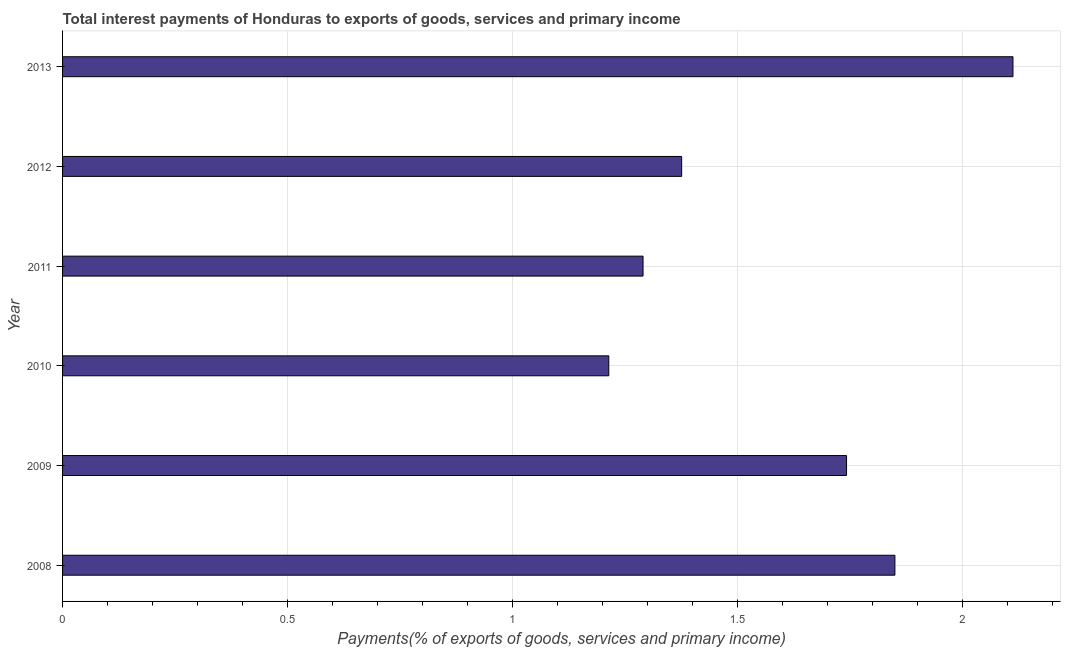Does the graph contain grids?
Provide a short and direct response. Yes. What is the title of the graph?
Your response must be concise. Total interest payments of Honduras to exports of goods, services and primary income. What is the label or title of the X-axis?
Provide a short and direct response. Payments(% of exports of goods, services and primary income). What is the total interest payments on external debt in 2008?
Offer a terse response. 1.85. Across all years, what is the maximum total interest payments on external debt?
Your response must be concise. 2.11. Across all years, what is the minimum total interest payments on external debt?
Provide a succinct answer. 1.21. In which year was the total interest payments on external debt maximum?
Provide a short and direct response. 2013. In which year was the total interest payments on external debt minimum?
Keep it short and to the point. 2010. What is the sum of the total interest payments on external debt?
Offer a terse response. 9.58. What is the difference between the total interest payments on external debt in 2010 and 2011?
Your answer should be compact. -0.08. What is the average total interest payments on external debt per year?
Provide a succinct answer. 1.6. What is the median total interest payments on external debt?
Give a very brief answer. 1.56. What is the ratio of the total interest payments on external debt in 2010 to that in 2012?
Ensure brevity in your answer.  0.88. Is the difference between the total interest payments on external debt in 2008 and 2009 greater than the difference between any two years?
Your answer should be very brief. No. What is the difference between the highest and the second highest total interest payments on external debt?
Ensure brevity in your answer.  0.26. What is the difference between the highest and the lowest total interest payments on external debt?
Provide a succinct answer. 0.9. In how many years, is the total interest payments on external debt greater than the average total interest payments on external debt taken over all years?
Keep it short and to the point. 3. Are all the bars in the graph horizontal?
Make the answer very short. Yes. What is the Payments(% of exports of goods, services and primary income) of 2008?
Offer a very short reply. 1.85. What is the Payments(% of exports of goods, services and primary income) of 2009?
Your response must be concise. 1.74. What is the Payments(% of exports of goods, services and primary income) in 2010?
Keep it short and to the point. 1.21. What is the Payments(% of exports of goods, services and primary income) in 2011?
Give a very brief answer. 1.29. What is the Payments(% of exports of goods, services and primary income) in 2012?
Provide a succinct answer. 1.38. What is the Payments(% of exports of goods, services and primary income) of 2013?
Provide a short and direct response. 2.11. What is the difference between the Payments(% of exports of goods, services and primary income) in 2008 and 2009?
Your answer should be compact. 0.11. What is the difference between the Payments(% of exports of goods, services and primary income) in 2008 and 2010?
Offer a very short reply. 0.64. What is the difference between the Payments(% of exports of goods, services and primary income) in 2008 and 2011?
Keep it short and to the point. 0.56. What is the difference between the Payments(% of exports of goods, services and primary income) in 2008 and 2012?
Offer a very short reply. 0.47. What is the difference between the Payments(% of exports of goods, services and primary income) in 2008 and 2013?
Your response must be concise. -0.26. What is the difference between the Payments(% of exports of goods, services and primary income) in 2009 and 2010?
Keep it short and to the point. 0.53. What is the difference between the Payments(% of exports of goods, services and primary income) in 2009 and 2011?
Offer a very short reply. 0.45. What is the difference between the Payments(% of exports of goods, services and primary income) in 2009 and 2012?
Offer a very short reply. 0.37. What is the difference between the Payments(% of exports of goods, services and primary income) in 2009 and 2013?
Provide a succinct answer. -0.37. What is the difference between the Payments(% of exports of goods, services and primary income) in 2010 and 2011?
Offer a terse response. -0.08. What is the difference between the Payments(% of exports of goods, services and primary income) in 2010 and 2012?
Keep it short and to the point. -0.16. What is the difference between the Payments(% of exports of goods, services and primary income) in 2010 and 2013?
Offer a terse response. -0.9. What is the difference between the Payments(% of exports of goods, services and primary income) in 2011 and 2012?
Your response must be concise. -0.09. What is the difference between the Payments(% of exports of goods, services and primary income) in 2011 and 2013?
Keep it short and to the point. -0.82. What is the difference between the Payments(% of exports of goods, services and primary income) in 2012 and 2013?
Make the answer very short. -0.74. What is the ratio of the Payments(% of exports of goods, services and primary income) in 2008 to that in 2009?
Provide a succinct answer. 1.06. What is the ratio of the Payments(% of exports of goods, services and primary income) in 2008 to that in 2010?
Offer a very short reply. 1.52. What is the ratio of the Payments(% of exports of goods, services and primary income) in 2008 to that in 2011?
Provide a short and direct response. 1.43. What is the ratio of the Payments(% of exports of goods, services and primary income) in 2008 to that in 2012?
Give a very brief answer. 1.34. What is the ratio of the Payments(% of exports of goods, services and primary income) in 2008 to that in 2013?
Your response must be concise. 0.88. What is the ratio of the Payments(% of exports of goods, services and primary income) in 2009 to that in 2010?
Ensure brevity in your answer.  1.44. What is the ratio of the Payments(% of exports of goods, services and primary income) in 2009 to that in 2011?
Your answer should be very brief. 1.35. What is the ratio of the Payments(% of exports of goods, services and primary income) in 2009 to that in 2012?
Your response must be concise. 1.27. What is the ratio of the Payments(% of exports of goods, services and primary income) in 2009 to that in 2013?
Your response must be concise. 0.82. What is the ratio of the Payments(% of exports of goods, services and primary income) in 2010 to that in 2011?
Make the answer very short. 0.94. What is the ratio of the Payments(% of exports of goods, services and primary income) in 2010 to that in 2012?
Keep it short and to the point. 0.88. What is the ratio of the Payments(% of exports of goods, services and primary income) in 2010 to that in 2013?
Offer a very short reply. 0.57. What is the ratio of the Payments(% of exports of goods, services and primary income) in 2011 to that in 2012?
Provide a succinct answer. 0.94. What is the ratio of the Payments(% of exports of goods, services and primary income) in 2011 to that in 2013?
Ensure brevity in your answer.  0.61. What is the ratio of the Payments(% of exports of goods, services and primary income) in 2012 to that in 2013?
Offer a very short reply. 0.65. 